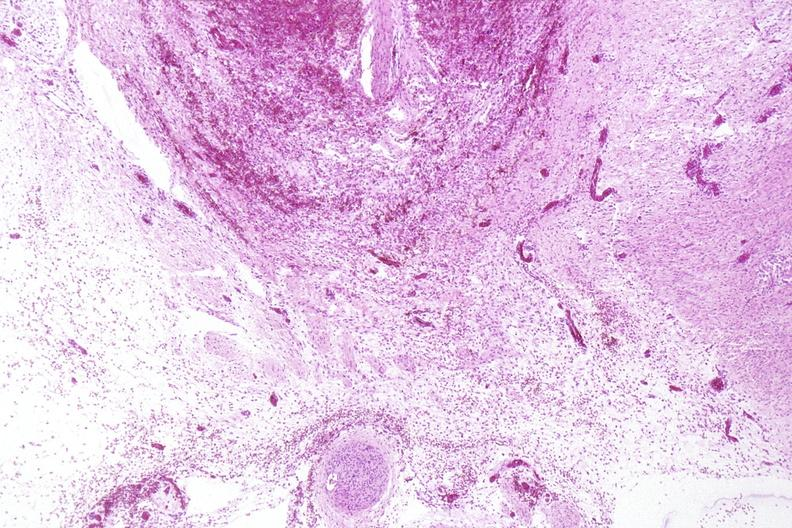s nervous present?
Answer the question using a single word or phrase. Yes 